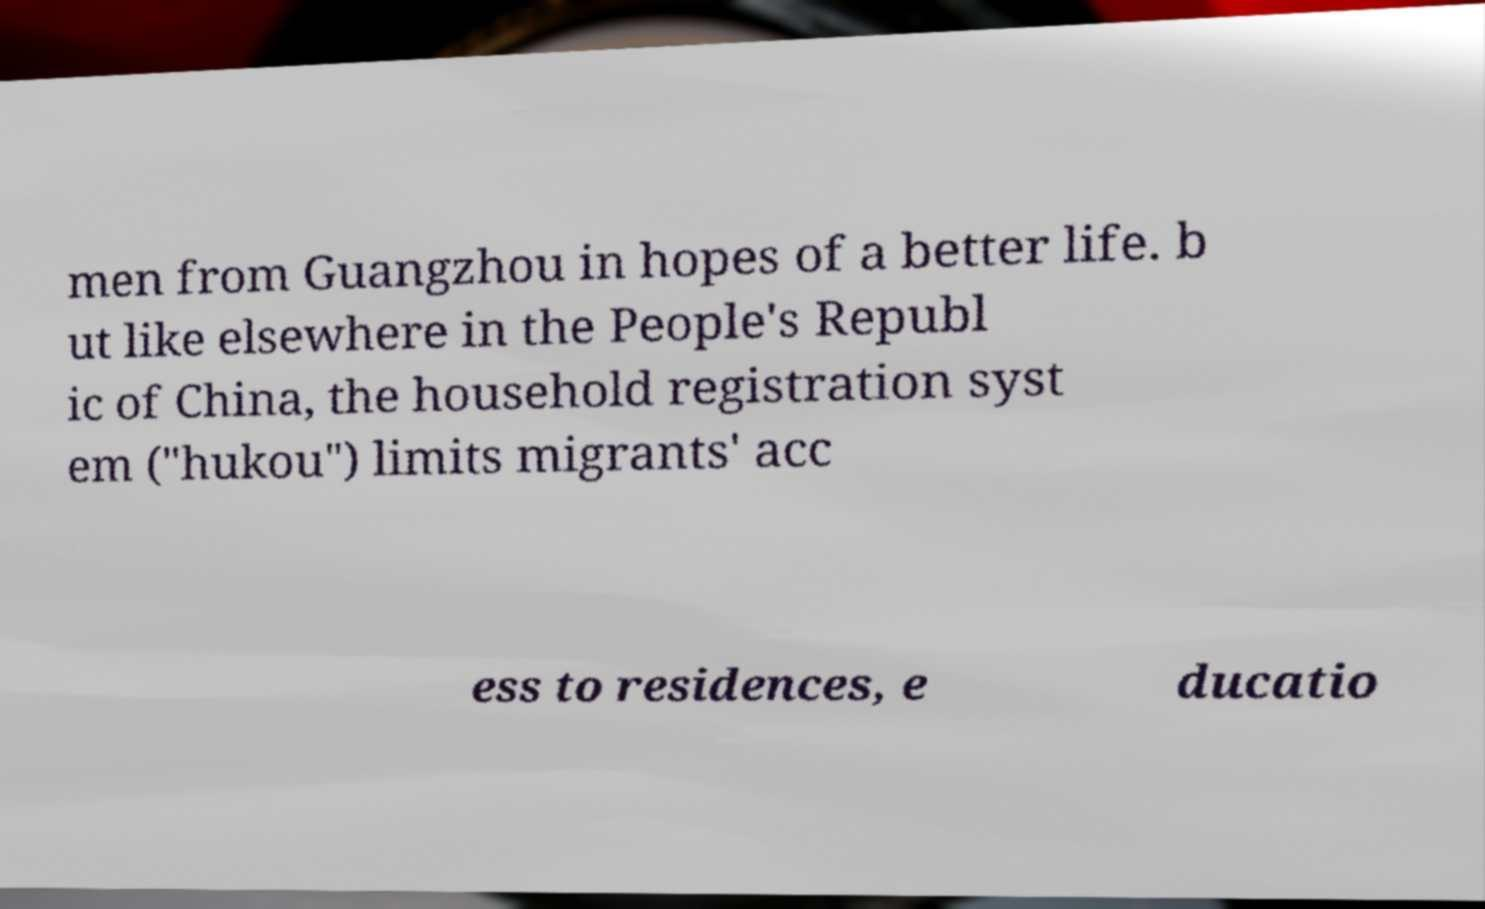What messages or text are displayed in this image? I need them in a readable, typed format. men from Guangzhou in hopes of a better life. b ut like elsewhere in the People's Republ ic of China, the household registration syst em ("hukou") limits migrants' acc ess to residences, e ducatio 